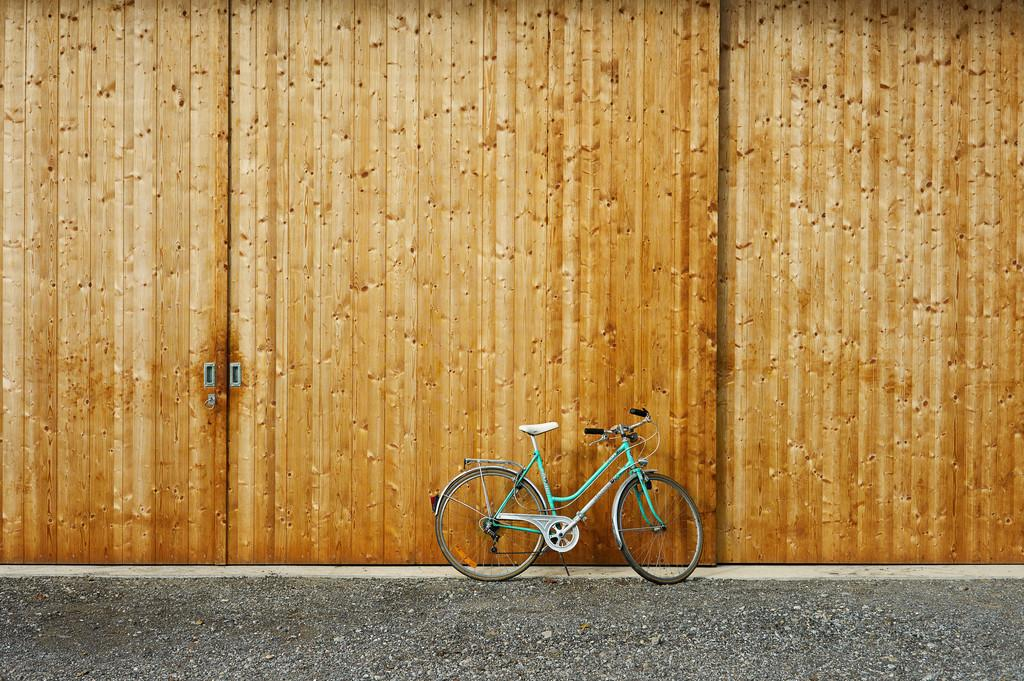What is the main object on the road in the image? There is a bicycle on the road in the image. What type of material is used for the wall-like structure in the image? The wall-like structure in the image is made of metal sheets. What type of rifle is being used by the spy in the image? There is no rifle or spy present in the image; it only features a bicycle on the road and a wall-like structure made of metal sheets. 